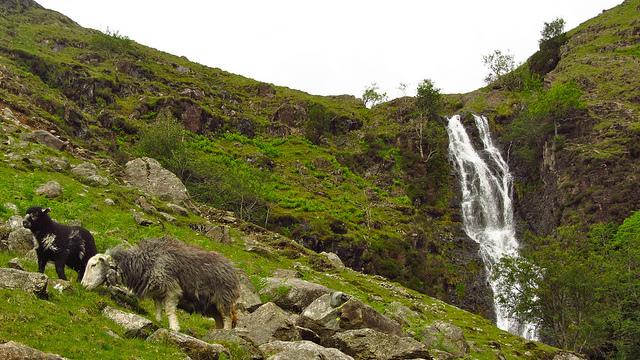Is this a natural waterfall?
Write a very short answer. Yes. Are the animals the same species?
Answer briefly. Yes. Are the animals content?
Keep it brief. Yes. 